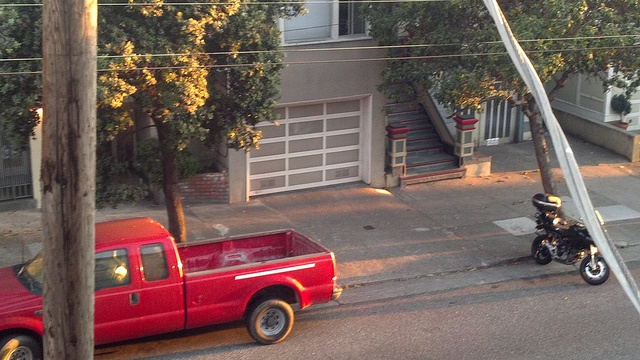Describe the objects in this image and their specific colors. I can see truck in gray, brown, black, and maroon tones, motorcycle in gray, black, and darkgray tones, potted plant in gray, maroon, and black tones, and potted plant in gray, black, purple, and darkgray tones in this image. 